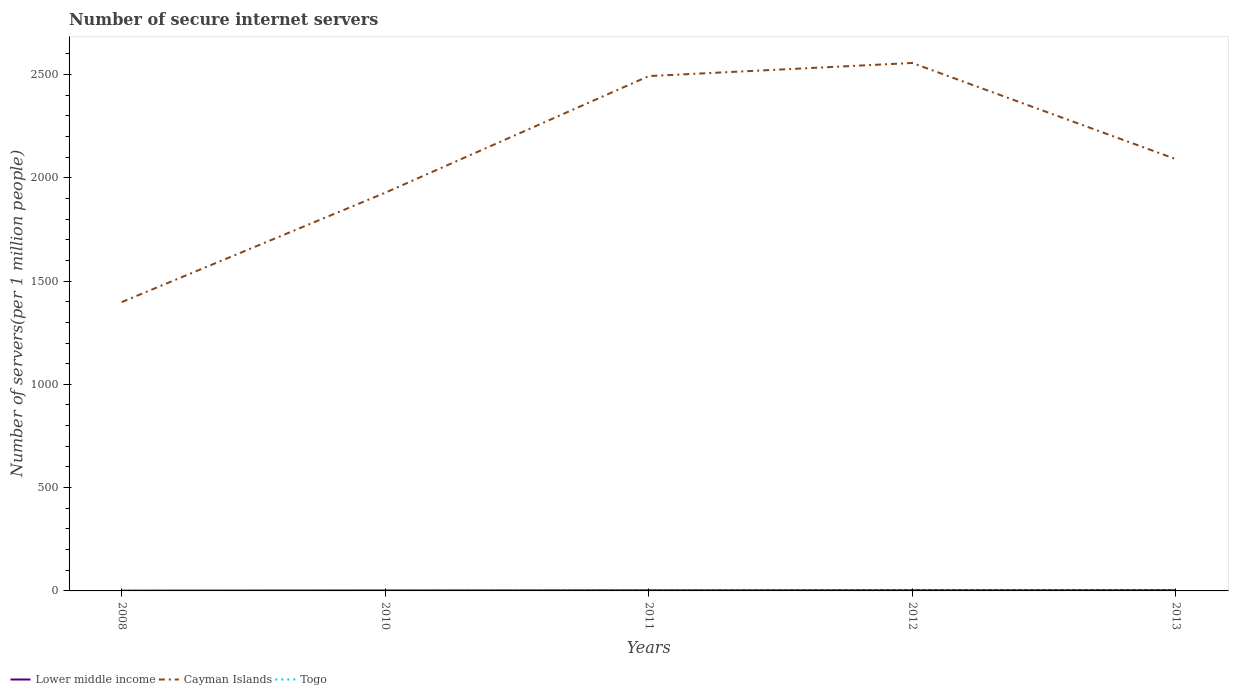How many different coloured lines are there?
Ensure brevity in your answer.  3. Does the line corresponding to Togo intersect with the line corresponding to Lower middle income?
Give a very brief answer. Yes. Across all years, what is the maximum number of secure internet servers in Cayman Islands?
Your answer should be compact. 1398.21. What is the total number of secure internet servers in Togo in the graph?
Give a very brief answer. -0.1. What is the difference between the highest and the second highest number of secure internet servers in Cayman Islands?
Give a very brief answer. 1157.34. What is the difference between the highest and the lowest number of secure internet servers in Lower middle income?
Your answer should be very brief. 3. What is the difference between two consecutive major ticks on the Y-axis?
Your answer should be very brief. 500. Are the values on the major ticks of Y-axis written in scientific E-notation?
Provide a short and direct response. No. What is the title of the graph?
Provide a succinct answer. Number of secure internet servers. What is the label or title of the Y-axis?
Provide a short and direct response. Number of servers(per 1 million people). What is the Number of servers(per 1 million people) of Lower middle income in 2008?
Ensure brevity in your answer.  1.31. What is the Number of servers(per 1 million people) of Cayman Islands in 2008?
Keep it short and to the point. 1398.21. What is the Number of servers(per 1 million people) of Togo in 2008?
Ensure brevity in your answer.  1.32. What is the Number of servers(per 1 million people) in Lower middle income in 2010?
Offer a very short reply. 2.33. What is the Number of servers(per 1 million people) of Cayman Islands in 2010?
Provide a short and direct response. 1927.62. What is the Number of servers(per 1 million people) of Togo in 2010?
Offer a terse response. 1.88. What is the Number of servers(per 1 million people) of Lower middle income in 2011?
Give a very brief answer. 3.15. What is the Number of servers(per 1 million people) in Cayman Islands in 2011?
Provide a succinct answer. 2492.05. What is the Number of servers(per 1 million people) of Togo in 2011?
Offer a very short reply. 1.98. What is the Number of servers(per 1 million people) of Lower middle income in 2012?
Give a very brief answer. 3.8. What is the Number of servers(per 1 million people) in Cayman Islands in 2012?
Provide a short and direct response. 2555.54. What is the Number of servers(per 1 million people) in Togo in 2012?
Your answer should be compact. 3.26. What is the Number of servers(per 1 million people) of Lower middle income in 2013?
Provide a short and direct response. 4.04. What is the Number of servers(per 1 million people) of Cayman Islands in 2013?
Provide a short and direct response. 2090.15. What is the Number of servers(per 1 million people) of Togo in 2013?
Offer a terse response. 3.03. Across all years, what is the maximum Number of servers(per 1 million people) of Lower middle income?
Your answer should be very brief. 4.04. Across all years, what is the maximum Number of servers(per 1 million people) in Cayman Islands?
Provide a short and direct response. 2555.54. Across all years, what is the maximum Number of servers(per 1 million people) of Togo?
Offer a very short reply. 3.26. Across all years, what is the minimum Number of servers(per 1 million people) of Lower middle income?
Offer a terse response. 1.31. Across all years, what is the minimum Number of servers(per 1 million people) of Cayman Islands?
Offer a terse response. 1398.21. Across all years, what is the minimum Number of servers(per 1 million people) in Togo?
Offer a very short reply. 1.32. What is the total Number of servers(per 1 million people) in Lower middle income in the graph?
Your answer should be very brief. 14.64. What is the total Number of servers(per 1 million people) in Cayman Islands in the graph?
Make the answer very short. 1.05e+04. What is the total Number of servers(per 1 million people) of Togo in the graph?
Give a very brief answer. 11.47. What is the difference between the Number of servers(per 1 million people) in Lower middle income in 2008 and that in 2010?
Make the answer very short. -1.02. What is the difference between the Number of servers(per 1 million people) in Cayman Islands in 2008 and that in 2010?
Provide a short and direct response. -529.41. What is the difference between the Number of servers(per 1 million people) in Togo in 2008 and that in 2010?
Make the answer very short. -0.56. What is the difference between the Number of servers(per 1 million people) of Lower middle income in 2008 and that in 2011?
Make the answer very short. -1.84. What is the difference between the Number of servers(per 1 million people) of Cayman Islands in 2008 and that in 2011?
Your response must be concise. -1093.84. What is the difference between the Number of servers(per 1 million people) of Togo in 2008 and that in 2011?
Your response must be concise. -0.66. What is the difference between the Number of servers(per 1 million people) in Lower middle income in 2008 and that in 2012?
Your answer should be very brief. -2.48. What is the difference between the Number of servers(per 1 million people) in Cayman Islands in 2008 and that in 2012?
Your answer should be very brief. -1157.34. What is the difference between the Number of servers(per 1 million people) of Togo in 2008 and that in 2012?
Provide a short and direct response. -1.94. What is the difference between the Number of servers(per 1 million people) of Lower middle income in 2008 and that in 2013?
Provide a short and direct response. -2.73. What is the difference between the Number of servers(per 1 million people) of Cayman Islands in 2008 and that in 2013?
Keep it short and to the point. -691.95. What is the difference between the Number of servers(per 1 million people) of Togo in 2008 and that in 2013?
Your answer should be compact. -1.71. What is the difference between the Number of servers(per 1 million people) of Lower middle income in 2010 and that in 2011?
Offer a very short reply. -0.82. What is the difference between the Number of servers(per 1 million people) in Cayman Islands in 2010 and that in 2011?
Offer a terse response. -564.43. What is the difference between the Number of servers(per 1 million people) in Togo in 2010 and that in 2011?
Offer a terse response. -0.1. What is the difference between the Number of servers(per 1 million people) in Lower middle income in 2010 and that in 2012?
Provide a succinct answer. -1.46. What is the difference between the Number of servers(per 1 million people) in Cayman Islands in 2010 and that in 2012?
Offer a terse response. -627.93. What is the difference between the Number of servers(per 1 million people) in Togo in 2010 and that in 2012?
Make the answer very short. -1.38. What is the difference between the Number of servers(per 1 million people) of Lower middle income in 2010 and that in 2013?
Ensure brevity in your answer.  -1.71. What is the difference between the Number of servers(per 1 million people) in Cayman Islands in 2010 and that in 2013?
Give a very brief answer. -162.54. What is the difference between the Number of servers(per 1 million people) of Togo in 2010 and that in 2013?
Your answer should be compact. -1.15. What is the difference between the Number of servers(per 1 million people) in Lower middle income in 2011 and that in 2012?
Offer a very short reply. -0.64. What is the difference between the Number of servers(per 1 million people) in Cayman Islands in 2011 and that in 2012?
Keep it short and to the point. -63.5. What is the difference between the Number of servers(per 1 million people) of Togo in 2011 and that in 2012?
Offer a terse response. -1.28. What is the difference between the Number of servers(per 1 million people) of Lower middle income in 2011 and that in 2013?
Keep it short and to the point. -0.89. What is the difference between the Number of servers(per 1 million people) in Cayman Islands in 2011 and that in 2013?
Your answer should be compact. 401.9. What is the difference between the Number of servers(per 1 million people) in Togo in 2011 and that in 2013?
Your answer should be compact. -1.05. What is the difference between the Number of servers(per 1 million people) of Lower middle income in 2012 and that in 2013?
Your answer should be very brief. -0.25. What is the difference between the Number of servers(per 1 million people) in Cayman Islands in 2012 and that in 2013?
Offer a terse response. 465.39. What is the difference between the Number of servers(per 1 million people) of Togo in 2012 and that in 2013?
Your answer should be compact. 0.23. What is the difference between the Number of servers(per 1 million people) of Lower middle income in 2008 and the Number of servers(per 1 million people) of Cayman Islands in 2010?
Keep it short and to the point. -1926.3. What is the difference between the Number of servers(per 1 million people) of Lower middle income in 2008 and the Number of servers(per 1 million people) of Togo in 2010?
Your response must be concise. -0.56. What is the difference between the Number of servers(per 1 million people) in Cayman Islands in 2008 and the Number of servers(per 1 million people) in Togo in 2010?
Provide a succinct answer. 1396.33. What is the difference between the Number of servers(per 1 million people) in Lower middle income in 2008 and the Number of servers(per 1 million people) in Cayman Islands in 2011?
Provide a short and direct response. -2490.73. What is the difference between the Number of servers(per 1 million people) of Lower middle income in 2008 and the Number of servers(per 1 million people) of Togo in 2011?
Your response must be concise. -0.67. What is the difference between the Number of servers(per 1 million people) in Cayman Islands in 2008 and the Number of servers(per 1 million people) in Togo in 2011?
Ensure brevity in your answer.  1396.23. What is the difference between the Number of servers(per 1 million people) of Lower middle income in 2008 and the Number of servers(per 1 million people) of Cayman Islands in 2012?
Keep it short and to the point. -2554.23. What is the difference between the Number of servers(per 1 million people) in Lower middle income in 2008 and the Number of servers(per 1 million people) in Togo in 2012?
Your response must be concise. -1.95. What is the difference between the Number of servers(per 1 million people) of Cayman Islands in 2008 and the Number of servers(per 1 million people) of Togo in 2012?
Your answer should be very brief. 1394.94. What is the difference between the Number of servers(per 1 million people) of Lower middle income in 2008 and the Number of servers(per 1 million people) of Cayman Islands in 2013?
Offer a very short reply. -2088.84. What is the difference between the Number of servers(per 1 million people) of Lower middle income in 2008 and the Number of servers(per 1 million people) of Togo in 2013?
Offer a very short reply. -1.72. What is the difference between the Number of servers(per 1 million people) in Cayman Islands in 2008 and the Number of servers(per 1 million people) in Togo in 2013?
Give a very brief answer. 1395.17. What is the difference between the Number of servers(per 1 million people) of Lower middle income in 2010 and the Number of servers(per 1 million people) of Cayman Islands in 2011?
Keep it short and to the point. -2489.71. What is the difference between the Number of servers(per 1 million people) in Lower middle income in 2010 and the Number of servers(per 1 million people) in Togo in 2011?
Keep it short and to the point. 0.35. What is the difference between the Number of servers(per 1 million people) in Cayman Islands in 2010 and the Number of servers(per 1 million people) in Togo in 2011?
Your answer should be compact. 1925.64. What is the difference between the Number of servers(per 1 million people) of Lower middle income in 2010 and the Number of servers(per 1 million people) of Cayman Islands in 2012?
Provide a succinct answer. -2553.21. What is the difference between the Number of servers(per 1 million people) in Lower middle income in 2010 and the Number of servers(per 1 million people) in Togo in 2012?
Give a very brief answer. -0.93. What is the difference between the Number of servers(per 1 million people) in Cayman Islands in 2010 and the Number of servers(per 1 million people) in Togo in 2012?
Your answer should be very brief. 1924.35. What is the difference between the Number of servers(per 1 million people) in Lower middle income in 2010 and the Number of servers(per 1 million people) in Cayman Islands in 2013?
Keep it short and to the point. -2087.82. What is the difference between the Number of servers(per 1 million people) of Lower middle income in 2010 and the Number of servers(per 1 million people) of Togo in 2013?
Your response must be concise. -0.7. What is the difference between the Number of servers(per 1 million people) of Cayman Islands in 2010 and the Number of servers(per 1 million people) of Togo in 2013?
Provide a succinct answer. 1924.58. What is the difference between the Number of servers(per 1 million people) in Lower middle income in 2011 and the Number of servers(per 1 million people) in Cayman Islands in 2012?
Your answer should be compact. -2552.39. What is the difference between the Number of servers(per 1 million people) in Lower middle income in 2011 and the Number of servers(per 1 million people) in Togo in 2012?
Ensure brevity in your answer.  -0.11. What is the difference between the Number of servers(per 1 million people) in Cayman Islands in 2011 and the Number of servers(per 1 million people) in Togo in 2012?
Keep it short and to the point. 2488.79. What is the difference between the Number of servers(per 1 million people) in Lower middle income in 2011 and the Number of servers(per 1 million people) in Cayman Islands in 2013?
Your answer should be compact. -2087. What is the difference between the Number of servers(per 1 million people) in Lower middle income in 2011 and the Number of servers(per 1 million people) in Togo in 2013?
Offer a terse response. 0.12. What is the difference between the Number of servers(per 1 million people) of Cayman Islands in 2011 and the Number of servers(per 1 million people) of Togo in 2013?
Offer a terse response. 2489.02. What is the difference between the Number of servers(per 1 million people) of Lower middle income in 2012 and the Number of servers(per 1 million people) of Cayman Islands in 2013?
Offer a terse response. -2086.35. What is the difference between the Number of servers(per 1 million people) in Lower middle income in 2012 and the Number of servers(per 1 million people) in Togo in 2013?
Keep it short and to the point. 0.77. What is the difference between the Number of servers(per 1 million people) in Cayman Islands in 2012 and the Number of servers(per 1 million people) in Togo in 2013?
Your answer should be compact. 2552.51. What is the average Number of servers(per 1 million people) in Lower middle income per year?
Provide a short and direct response. 2.93. What is the average Number of servers(per 1 million people) in Cayman Islands per year?
Your answer should be very brief. 2092.71. What is the average Number of servers(per 1 million people) in Togo per year?
Your answer should be very brief. 2.29. In the year 2008, what is the difference between the Number of servers(per 1 million people) in Lower middle income and Number of servers(per 1 million people) in Cayman Islands?
Make the answer very short. -1396.89. In the year 2008, what is the difference between the Number of servers(per 1 million people) of Lower middle income and Number of servers(per 1 million people) of Togo?
Provide a succinct answer. -0.01. In the year 2008, what is the difference between the Number of servers(per 1 million people) of Cayman Islands and Number of servers(per 1 million people) of Togo?
Your response must be concise. 1396.88. In the year 2010, what is the difference between the Number of servers(per 1 million people) of Lower middle income and Number of servers(per 1 million people) of Cayman Islands?
Your answer should be compact. -1925.28. In the year 2010, what is the difference between the Number of servers(per 1 million people) of Lower middle income and Number of servers(per 1 million people) of Togo?
Provide a succinct answer. 0.46. In the year 2010, what is the difference between the Number of servers(per 1 million people) in Cayman Islands and Number of servers(per 1 million people) in Togo?
Provide a succinct answer. 1925.74. In the year 2011, what is the difference between the Number of servers(per 1 million people) in Lower middle income and Number of servers(per 1 million people) in Cayman Islands?
Your answer should be very brief. -2488.89. In the year 2011, what is the difference between the Number of servers(per 1 million people) in Lower middle income and Number of servers(per 1 million people) in Togo?
Your answer should be very brief. 1.17. In the year 2011, what is the difference between the Number of servers(per 1 million people) in Cayman Islands and Number of servers(per 1 million people) in Togo?
Your answer should be compact. 2490.07. In the year 2012, what is the difference between the Number of servers(per 1 million people) of Lower middle income and Number of servers(per 1 million people) of Cayman Islands?
Your response must be concise. -2551.75. In the year 2012, what is the difference between the Number of servers(per 1 million people) in Lower middle income and Number of servers(per 1 million people) in Togo?
Provide a short and direct response. 0.54. In the year 2012, what is the difference between the Number of servers(per 1 million people) of Cayman Islands and Number of servers(per 1 million people) of Togo?
Offer a very short reply. 2552.28. In the year 2013, what is the difference between the Number of servers(per 1 million people) in Lower middle income and Number of servers(per 1 million people) in Cayman Islands?
Provide a succinct answer. -2086.11. In the year 2013, what is the difference between the Number of servers(per 1 million people) in Lower middle income and Number of servers(per 1 million people) in Togo?
Offer a very short reply. 1.01. In the year 2013, what is the difference between the Number of servers(per 1 million people) of Cayman Islands and Number of servers(per 1 million people) of Togo?
Make the answer very short. 2087.12. What is the ratio of the Number of servers(per 1 million people) of Lower middle income in 2008 to that in 2010?
Provide a short and direct response. 0.56. What is the ratio of the Number of servers(per 1 million people) of Cayman Islands in 2008 to that in 2010?
Provide a succinct answer. 0.73. What is the ratio of the Number of servers(per 1 million people) in Togo in 2008 to that in 2010?
Provide a short and direct response. 0.7. What is the ratio of the Number of servers(per 1 million people) in Lower middle income in 2008 to that in 2011?
Offer a terse response. 0.42. What is the ratio of the Number of servers(per 1 million people) of Cayman Islands in 2008 to that in 2011?
Provide a short and direct response. 0.56. What is the ratio of the Number of servers(per 1 million people) in Togo in 2008 to that in 2011?
Make the answer very short. 0.67. What is the ratio of the Number of servers(per 1 million people) of Lower middle income in 2008 to that in 2012?
Provide a short and direct response. 0.35. What is the ratio of the Number of servers(per 1 million people) of Cayman Islands in 2008 to that in 2012?
Make the answer very short. 0.55. What is the ratio of the Number of servers(per 1 million people) of Togo in 2008 to that in 2012?
Provide a short and direct response. 0.41. What is the ratio of the Number of servers(per 1 million people) in Lower middle income in 2008 to that in 2013?
Provide a succinct answer. 0.32. What is the ratio of the Number of servers(per 1 million people) of Cayman Islands in 2008 to that in 2013?
Provide a succinct answer. 0.67. What is the ratio of the Number of servers(per 1 million people) of Togo in 2008 to that in 2013?
Offer a very short reply. 0.44. What is the ratio of the Number of servers(per 1 million people) in Lower middle income in 2010 to that in 2011?
Your answer should be compact. 0.74. What is the ratio of the Number of servers(per 1 million people) in Cayman Islands in 2010 to that in 2011?
Your answer should be compact. 0.77. What is the ratio of the Number of servers(per 1 million people) of Togo in 2010 to that in 2011?
Offer a very short reply. 0.95. What is the ratio of the Number of servers(per 1 million people) in Lower middle income in 2010 to that in 2012?
Offer a terse response. 0.61. What is the ratio of the Number of servers(per 1 million people) of Cayman Islands in 2010 to that in 2012?
Keep it short and to the point. 0.75. What is the ratio of the Number of servers(per 1 million people) in Togo in 2010 to that in 2012?
Give a very brief answer. 0.58. What is the ratio of the Number of servers(per 1 million people) in Lower middle income in 2010 to that in 2013?
Your response must be concise. 0.58. What is the ratio of the Number of servers(per 1 million people) of Cayman Islands in 2010 to that in 2013?
Keep it short and to the point. 0.92. What is the ratio of the Number of servers(per 1 million people) of Togo in 2010 to that in 2013?
Your answer should be very brief. 0.62. What is the ratio of the Number of servers(per 1 million people) of Lower middle income in 2011 to that in 2012?
Ensure brevity in your answer.  0.83. What is the ratio of the Number of servers(per 1 million people) in Cayman Islands in 2011 to that in 2012?
Make the answer very short. 0.98. What is the ratio of the Number of servers(per 1 million people) in Togo in 2011 to that in 2012?
Provide a succinct answer. 0.61. What is the ratio of the Number of servers(per 1 million people) of Lower middle income in 2011 to that in 2013?
Your answer should be very brief. 0.78. What is the ratio of the Number of servers(per 1 million people) of Cayman Islands in 2011 to that in 2013?
Ensure brevity in your answer.  1.19. What is the ratio of the Number of servers(per 1 million people) in Togo in 2011 to that in 2013?
Offer a very short reply. 0.65. What is the ratio of the Number of servers(per 1 million people) of Lower middle income in 2012 to that in 2013?
Offer a terse response. 0.94. What is the ratio of the Number of servers(per 1 million people) of Cayman Islands in 2012 to that in 2013?
Offer a very short reply. 1.22. What is the ratio of the Number of servers(per 1 million people) of Togo in 2012 to that in 2013?
Offer a terse response. 1.08. What is the difference between the highest and the second highest Number of servers(per 1 million people) in Lower middle income?
Ensure brevity in your answer.  0.25. What is the difference between the highest and the second highest Number of servers(per 1 million people) in Cayman Islands?
Make the answer very short. 63.5. What is the difference between the highest and the second highest Number of servers(per 1 million people) of Togo?
Provide a short and direct response. 0.23. What is the difference between the highest and the lowest Number of servers(per 1 million people) in Lower middle income?
Keep it short and to the point. 2.73. What is the difference between the highest and the lowest Number of servers(per 1 million people) in Cayman Islands?
Your answer should be compact. 1157.34. What is the difference between the highest and the lowest Number of servers(per 1 million people) of Togo?
Offer a very short reply. 1.94. 